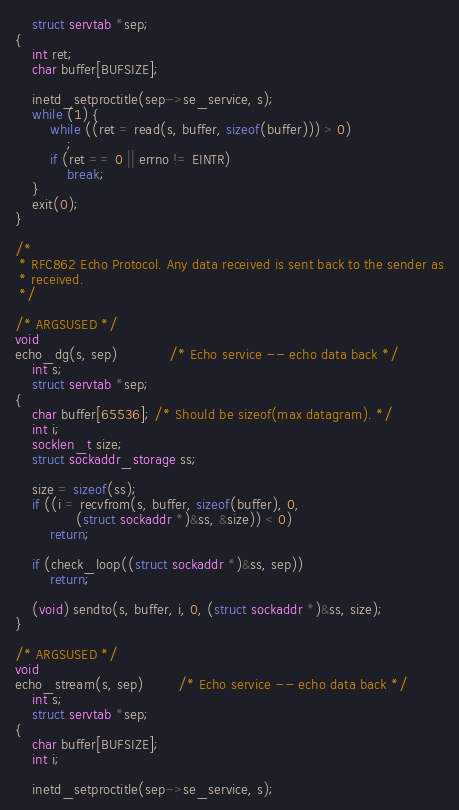Convert code to text. <code><loc_0><loc_0><loc_500><loc_500><_C_>	struct servtab *sep;
{
	int ret;
	char buffer[BUFSIZE];

	inetd_setproctitle(sep->se_service, s);
	while (1) {
		while ((ret = read(s, buffer, sizeof(buffer))) > 0)
			;
		if (ret == 0 || errno != EINTR)
			break;
	}
	exit(0);
}

/*
 * RFC862 Echo Protocol. Any data received is sent back to the sender as
 * received.
 */

/* ARGSUSED */
void
echo_dg(s, sep)			/* Echo service -- echo data back */
	int s;
	struct servtab *sep;
{
	char buffer[65536]; /* Should be sizeof(max datagram). */
	int i;
	socklen_t size;
	struct sockaddr_storage ss;

	size = sizeof(ss);
	if ((i = recvfrom(s, buffer, sizeof(buffer), 0,
			  (struct sockaddr *)&ss, &size)) < 0)
		return;

	if (check_loop((struct sockaddr *)&ss, sep))
		return;

	(void) sendto(s, buffer, i, 0, (struct sockaddr *)&ss, size);
}

/* ARGSUSED */
void
echo_stream(s, sep)		/* Echo service -- echo data back */
	int s;
	struct servtab *sep;
{
	char buffer[BUFSIZE];
	int i;

	inetd_setproctitle(sep->se_service, s);</code> 